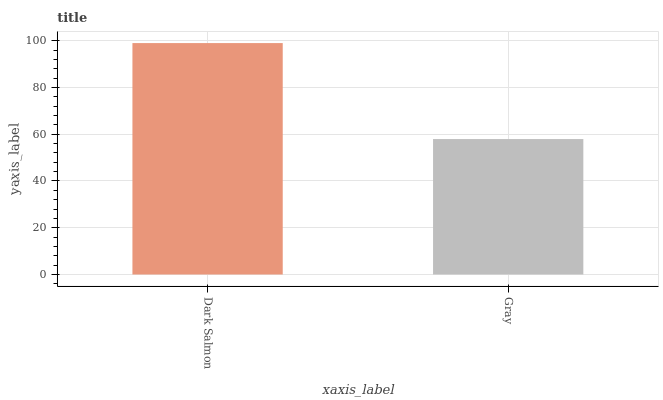Is Gray the minimum?
Answer yes or no. Yes. Is Dark Salmon the maximum?
Answer yes or no. Yes. Is Gray the maximum?
Answer yes or no. No. Is Dark Salmon greater than Gray?
Answer yes or no. Yes. Is Gray less than Dark Salmon?
Answer yes or no. Yes. Is Gray greater than Dark Salmon?
Answer yes or no. No. Is Dark Salmon less than Gray?
Answer yes or no. No. Is Dark Salmon the high median?
Answer yes or no. Yes. Is Gray the low median?
Answer yes or no. Yes. Is Gray the high median?
Answer yes or no. No. Is Dark Salmon the low median?
Answer yes or no. No. 